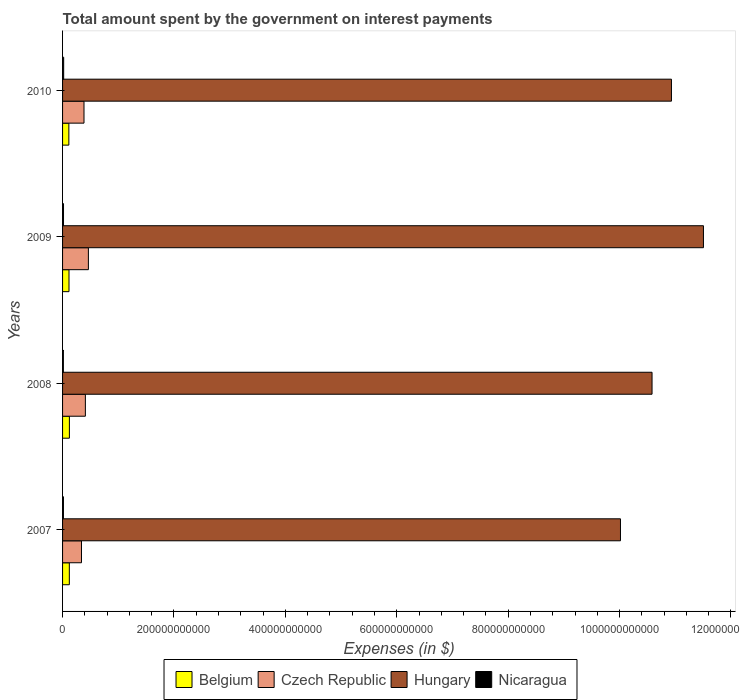How many different coloured bars are there?
Make the answer very short. 4. How many groups of bars are there?
Offer a very short reply. 4. Are the number of bars per tick equal to the number of legend labels?
Your response must be concise. Yes. What is the label of the 3rd group of bars from the top?
Ensure brevity in your answer.  2008. What is the amount spent on interest payments by the government in Hungary in 2007?
Offer a very short reply. 1.00e+12. Across all years, what is the maximum amount spent on interest payments by the government in Nicaragua?
Keep it short and to the point. 1.99e+09. Across all years, what is the minimum amount spent on interest payments by the government in Czech Republic?
Your answer should be compact. 3.40e+1. What is the total amount spent on interest payments by the government in Hungary in the graph?
Offer a very short reply. 4.30e+12. What is the difference between the amount spent on interest payments by the government in Hungary in 2007 and that in 2008?
Ensure brevity in your answer.  -5.67e+1. What is the difference between the amount spent on interest payments by the government in Hungary in 2010 and the amount spent on interest payments by the government in Nicaragua in 2009?
Keep it short and to the point. 1.09e+12. What is the average amount spent on interest payments by the government in Hungary per year?
Make the answer very short. 1.08e+12. In the year 2008, what is the difference between the amount spent on interest payments by the government in Nicaragua and amount spent on interest payments by the government in Hungary?
Give a very brief answer. -1.06e+12. In how many years, is the amount spent on interest payments by the government in Czech Republic greater than 720000000000 $?
Your response must be concise. 0. What is the ratio of the amount spent on interest payments by the government in Belgium in 2008 to that in 2009?
Your answer should be compact. 1.06. Is the amount spent on interest payments by the government in Nicaragua in 2008 less than that in 2009?
Provide a succinct answer. Yes. Is the difference between the amount spent on interest payments by the government in Nicaragua in 2007 and 2010 greater than the difference between the amount spent on interest payments by the government in Hungary in 2007 and 2010?
Offer a terse response. Yes. What is the difference between the highest and the second highest amount spent on interest payments by the government in Hungary?
Provide a succinct answer. 5.74e+1. What is the difference between the highest and the lowest amount spent on interest payments by the government in Czech Republic?
Offer a terse response. 1.24e+1. Is it the case that in every year, the sum of the amount spent on interest payments by the government in Nicaragua and amount spent on interest payments by the government in Hungary is greater than the sum of amount spent on interest payments by the government in Belgium and amount spent on interest payments by the government in Czech Republic?
Offer a very short reply. No. What does the 3rd bar from the top in 2009 represents?
Offer a terse response. Czech Republic. What does the 3rd bar from the bottom in 2009 represents?
Provide a short and direct response. Hungary. How many years are there in the graph?
Make the answer very short. 4. What is the difference between two consecutive major ticks on the X-axis?
Keep it short and to the point. 2.00e+11. How many legend labels are there?
Provide a succinct answer. 4. How are the legend labels stacked?
Offer a terse response. Horizontal. What is the title of the graph?
Your answer should be compact. Total amount spent by the government on interest payments. Does "Luxembourg" appear as one of the legend labels in the graph?
Provide a succinct answer. No. What is the label or title of the X-axis?
Provide a short and direct response. Expenses (in $). What is the label or title of the Y-axis?
Offer a very short reply. Years. What is the Expenses (in $) in Belgium in 2007?
Your answer should be compact. 1.21e+1. What is the Expenses (in $) in Czech Republic in 2007?
Your response must be concise. 3.40e+1. What is the Expenses (in $) of Hungary in 2007?
Provide a succinct answer. 1.00e+12. What is the Expenses (in $) in Nicaragua in 2007?
Provide a short and direct response. 1.58e+09. What is the Expenses (in $) in Belgium in 2008?
Your answer should be compact. 1.23e+1. What is the Expenses (in $) in Czech Republic in 2008?
Keep it short and to the point. 4.09e+1. What is the Expenses (in $) of Hungary in 2008?
Offer a terse response. 1.06e+12. What is the Expenses (in $) in Nicaragua in 2008?
Offer a terse response. 1.45e+09. What is the Expenses (in $) of Belgium in 2009?
Give a very brief answer. 1.16e+1. What is the Expenses (in $) in Czech Republic in 2009?
Give a very brief answer. 4.64e+1. What is the Expenses (in $) of Hungary in 2009?
Provide a short and direct response. 1.15e+12. What is the Expenses (in $) of Nicaragua in 2009?
Keep it short and to the point. 1.71e+09. What is the Expenses (in $) of Belgium in 2010?
Provide a short and direct response. 1.13e+1. What is the Expenses (in $) in Czech Republic in 2010?
Ensure brevity in your answer.  3.85e+1. What is the Expenses (in $) of Hungary in 2010?
Provide a short and direct response. 1.09e+12. What is the Expenses (in $) in Nicaragua in 2010?
Ensure brevity in your answer.  1.99e+09. Across all years, what is the maximum Expenses (in $) in Belgium?
Offer a very short reply. 1.23e+1. Across all years, what is the maximum Expenses (in $) in Czech Republic?
Your answer should be compact. 4.64e+1. Across all years, what is the maximum Expenses (in $) in Hungary?
Offer a terse response. 1.15e+12. Across all years, what is the maximum Expenses (in $) in Nicaragua?
Your answer should be very brief. 1.99e+09. Across all years, what is the minimum Expenses (in $) in Belgium?
Make the answer very short. 1.13e+1. Across all years, what is the minimum Expenses (in $) of Czech Republic?
Make the answer very short. 3.40e+1. Across all years, what is the minimum Expenses (in $) in Hungary?
Your response must be concise. 1.00e+12. Across all years, what is the minimum Expenses (in $) in Nicaragua?
Keep it short and to the point. 1.45e+09. What is the total Expenses (in $) of Belgium in the graph?
Ensure brevity in your answer.  4.72e+1. What is the total Expenses (in $) of Czech Republic in the graph?
Keep it short and to the point. 1.60e+11. What is the total Expenses (in $) of Hungary in the graph?
Your answer should be compact. 4.30e+12. What is the total Expenses (in $) in Nicaragua in the graph?
Offer a very short reply. 6.73e+09. What is the difference between the Expenses (in $) of Belgium in 2007 and that in 2008?
Provide a succinct answer. -1.29e+08. What is the difference between the Expenses (in $) in Czech Republic in 2007 and that in 2008?
Your response must be concise. -6.98e+09. What is the difference between the Expenses (in $) in Hungary in 2007 and that in 2008?
Offer a terse response. -5.67e+1. What is the difference between the Expenses (in $) in Nicaragua in 2007 and that in 2008?
Offer a very short reply. 1.32e+08. What is the difference between the Expenses (in $) in Belgium in 2007 and that in 2009?
Give a very brief answer. 5.78e+08. What is the difference between the Expenses (in $) of Czech Republic in 2007 and that in 2009?
Provide a short and direct response. -1.24e+1. What is the difference between the Expenses (in $) in Hungary in 2007 and that in 2009?
Ensure brevity in your answer.  -1.49e+11. What is the difference between the Expenses (in $) in Nicaragua in 2007 and that in 2009?
Offer a very short reply. -1.31e+08. What is the difference between the Expenses (in $) in Belgium in 2007 and that in 2010?
Ensure brevity in your answer.  8.33e+08. What is the difference between the Expenses (in $) in Czech Republic in 2007 and that in 2010?
Provide a short and direct response. -4.53e+09. What is the difference between the Expenses (in $) in Hungary in 2007 and that in 2010?
Make the answer very short. -9.15e+1. What is the difference between the Expenses (in $) in Nicaragua in 2007 and that in 2010?
Keep it short and to the point. -4.11e+08. What is the difference between the Expenses (in $) in Belgium in 2008 and that in 2009?
Ensure brevity in your answer.  7.06e+08. What is the difference between the Expenses (in $) of Czech Republic in 2008 and that in 2009?
Keep it short and to the point. -5.42e+09. What is the difference between the Expenses (in $) in Hungary in 2008 and that in 2009?
Ensure brevity in your answer.  -9.23e+1. What is the difference between the Expenses (in $) of Nicaragua in 2008 and that in 2009?
Ensure brevity in your answer.  -2.64e+08. What is the difference between the Expenses (in $) in Belgium in 2008 and that in 2010?
Give a very brief answer. 9.62e+08. What is the difference between the Expenses (in $) of Czech Republic in 2008 and that in 2010?
Your answer should be compact. 2.45e+09. What is the difference between the Expenses (in $) of Hungary in 2008 and that in 2010?
Your answer should be compact. -3.49e+1. What is the difference between the Expenses (in $) of Nicaragua in 2008 and that in 2010?
Ensure brevity in your answer.  -5.43e+08. What is the difference between the Expenses (in $) of Belgium in 2009 and that in 2010?
Offer a terse response. 2.56e+08. What is the difference between the Expenses (in $) in Czech Republic in 2009 and that in 2010?
Your answer should be very brief. 7.87e+09. What is the difference between the Expenses (in $) of Hungary in 2009 and that in 2010?
Offer a very short reply. 5.74e+1. What is the difference between the Expenses (in $) of Nicaragua in 2009 and that in 2010?
Provide a succinct answer. -2.79e+08. What is the difference between the Expenses (in $) of Belgium in 2007 and the Expenses (in $) of Czech Republic in 2008?
Your answer should be compact. -2.88e+1. What is the difference between the Expenses (in $) of Belgium in 2007 and the Expenses (in $) of Hungary in 2008?
Provide a short and direct response. -1.05e+12. What is the difference between the Expenses (in $) in Belgium in 2007 and the Expenses (in $) in Nicaragua in 2008?
Offer a terse response. 1.07e+1. What is the difference between the Expenses (in $) of Czech Republic in 2007 and the Expenses (in $) of Hungary in 2008?
Keep it short and to the point. -1.02e+12. What is the difference between the Expenses (in $) in Czech Republic in 2007 and the Expenses (in $) in Nicaragua in 2008?
Keep it short and to the point. 3.25e+1. What is the difference between the Expenses (in $) in Hungary in 2007 and the Expenses (in $) in Nicaragua in 2008?
Keep it short and to the point. 1.00e+12. What is the difference between the Expenses (in $) of Belgium in 2007 and the Expenses (in $) of Czech Republic in 2009?
Provide a succinct answer. -3.42e+1. What is the difference between the Expenses (in $) of Belgium in 2007 and the Expenses (in $) of Hungary in 2009?
Ensure brevity in your answer.  -1.14e+12. What is the difference between the Expenses (in $) in Belgium in 2007 and the Expenses (in $) in Nicaragua in 2009?
Ensure brevity in your answer.  1.04e+1. What is the difference between the Expenses (in $) in Czech Republic in 2007 and the Expenses (in $) in Hungary in 2009?
Give a very brief answer. -1.12e+12. What is the difference between the Expenses (in $) in Czech Republic in 2007 and the Expenses (in $) in Nicaragua in 2009?
Make the answer very short. 3.23e+1. What is the difference between the Expenses (in $) of Hungary in 2007 and the Expenses (in $) of Nicaragua in 2009?
Offer a very short reply. 1.00e+12. What is the difference between the Expenses (in $) of Belgium in 2007 and the Expenses (in $) of Czech Republic in 2010?
Provide a succinct answer. -2.64e+1. What is the difference between the Expenses (in $) of Belgium in 2007 and the Expenses (in $) of Hungary in 2010?
Your response must be concise. -1.08e+12. What is the difference between the Expenses (in $) in Belgium in 2007 and the Expenses (in $) in Nicaragua in 2010?
Provide a succinct answer. 1.01e+1. What is the difference between the Expenses (in $) of Czech Republic in 2007 and the Expenses (in $) of Hungary in 2010?
Provide a short and direct response. -1.06e+12. What is the difference between the Expenses (in $) of Czech Republic in 2007 and the Expenses (in $) of Nicaragua in 2010?
Ensure brevity in your answer.  3.20e+1. What is the difference between the Expenses (in $) in Hungary in 2007 and the Expenses (in $) in Nicaragua in 2010?
Ensure brevity in your answer.  1.00e+12. What is the difference between the Expenses (in $) in Belgium in 2008 and the Expenses (in $) in Czech Republic in 2009?
Provide a short and direct response. -3.41e+1. What is the difference between the Expenses (in $) of Belgium in 2008 and the Expenses (in $) of Hungary in 2009?
Your response must be concise. -1.14e+12. What is the difference between the Expenses (in $) in Belgium in 2008 and the Expenses (in $) in Nicaragua in 2009?
Ensure brevity in your answer.  1.05e+1. What is the difference between the Expenses (in $) of Czech Republic in 2008 and the Expenses (in $) of Hungary in 2009?
Make the answer very short. -1.11e+12. What is the difference between the Expenses (in $) in Czech Republic in 2008 and the Expenses (in $) in Nicaragua in 2009?
Your answer should be very brief. 3.92e+1. What is the difference between the Expenses (in $) in Hungary in 2008 and the Expenses (in $) in Nicaragua in 2009?
Provide a short and direct response. 1.06e+12. What is the difference between the Expenses (in $) of Belgium in 2008 and the Expenses (in $) of Czech Republic in 2010?
Your answer should be very brief. -2.62e+1. What is the difference between the Expenses (in $) in Belgium in 2008 and the Expenses (in $) in Hungary in 2010?
Your answer should be compact. -1.08e+12. What is the difference between the Expenses (in $) in Belgium in 2008 and the Expenses (in $) in Nicaragua in 2010?
Offer a terse response. 1.03e+1. What is the difference between the Expenses (in $) of Czech Republic in 2008 and the Expenses (in $) of Hungary in 2010?
Provide a succinct answer. -1.05e+12. What is the difference between the Expenses (in $) of Czech Republic in 2008 and the Expenses (in $) of Nicaragua in 2010?
Ensure brevity in your answer.  3.90e+1. What is the difference between the Expenses (in $) in Hungary in 2008 and the Expenses (in $) in Nicaragua in 2010?
Your response must be concise. 1.06e+12. What is the difference between the Expenses (in $) of Belgium in 2009 and the Expenses (in $) of Czech Republic in 2010?
Offer a terse response. -2.69e+1. What is the difference between the Expenses (in $) in Belgium in 2009 and the Expenses (in $) in Hungary in 2010?
Your response must be concise. -1.08e+12. What is the difference between the Expenses (in $) in Belgium in 2009 and the Expenses (in $) in Nicaragua in 2010?
Your answer should be very brief. 9.56e+09. What is the difference between the Expenses (in $) of Czech Republic in 2009 and the Expenses (in $) of Hungary in 2010?
Offer a terse response. -1.05e+12. What is the difference between the Expenses (in $) in Czech Republic in 2009 and the Expenses (in $) in Nicaragua in 2010?
Keep it short and to the point. 4.44e+1. What is the difference between the Expenses (in $) in Hungary in 2009 and the Expenses (in $) in Nicaragua in 2010?
Make the answer very short. 1.15e+12. What is the average Expenses (in $) in Belgium per year?
Keep it short and to the point. 1.18e+1. What is the average Expenses (in $) in Czech Republic per year?
Keep it short and to the point. 3.99e+1. What is the average Expenses (in $) in Hungary per year?
Keep it short and to the point. 1.08e+12. What is the average Expenses (in $) of Nicaragua per year?
Keep it short and to the point. 1.68e+09. In the year 2007, what is the difference between the Expenses (in $) of Belgium and Expenses (in $) of Czech Republic?
Keep it short and to the point. -2.18e+1. In the year 2007, what is the difference between the Expenses (in $) in Belgium and Expenses (in $) in Hungary?
Your response must be concise. -9.89e+11. In the year 2007, what is the difference between the Expenses (in $) of Belgium and Expenses (in $) of Nicaragua?
Your answer should be very brief. 1.06e+1. In the year 2007, what is the difference between the Expenses (in $) of Czech Republic and Expenses (in $) of Hungary?
Ensure brevity in your answer.  -9.68e+11. In the year 2007, what is the difference between the Expenses (in $) of Czech Republic and Expenses (in $) of Nicaragua?
Your response must be concise. 3.24e+1. In the year 2007, what is the difference between the Expenses (in $) of Hungary and Expenses (in $) of Nicaragua?
Provide a short and direct response. 1.00e+12. In the year 2008, what is the difference between the Expenses (in $) in Belgium and Expenses (in $) in Czech Republic?
Offer a terse response. -2.87e+1. In the year 2008, what is the difference between the Expenses (in $) of Belgium and Expenses (in $) of Hungary?
Ensure brevity in your answer.  -1.05e+12. In the year 2008, what is the difference between the Expenses (in $) in Belgium and Expenses (in $) in Nicaragua?
Offer a very short reply. 1.08e+1. In the year 2008, what is the difference between the Expenses (in $) in Czech Republic and Expenses (in $) in Hungary?
Offer a terse response. -1.02e+12. In the year 2008, what is the difference between the Expenses (in $) in Czech Republic and Expenses (in $) in Nicaragua?
Ensure brevity in your answer.  3.95e+1. In the year 2008, what is the difference between the Expenses (in $) in Hungary and Expenses (in $) in Nicaragua?
Offer a terse response. 1.06e+12. In the year 2009, what is the difference between the Expenses (in $) of Belgium and Expenses (in $) of Czech Republic?
Give a very brief answer. -3.48e+1. In the year 2009, what is the difference between the Expenses (in $) of Belgium and Expenses (in $) of Hungary?
Provide a short and direct response. -1.14e+12. In the year 2009, what is the difference between the Expenses (in $) of Belgium and Expenses (in $) of Nicaragua?
Make the answer very short. 9.84e+09. In the year 2009, what is the difference between the Expenses (in $) of Czech Republic and Expenses (in $) of Hungary?
Your answer should be compact. -1.10e+12. In the year 2009, what is the difference between the Expenses (in $) in Czech Republic and Expenses (in $) in Nicaragua?
Ensure brevity in your answer.  4.47e+1. In the year 2009, what is the difference between the Expenses (in $) in Hungary and Expenses (in $) in Nicaragua?
Offer a terse response. 1.15e+12. In the year 2010, what is the difference between the Expenses (in $) of Belgium and Expenses (in $) of Czech Republic?
Your answer should be very brief. -2.72e+1. In the year 2010, what is the difference between the Expenses (in $) of Belgium and Expenses (in $) of Hungary?
Your answer should be very brief. -1.08e+12. In the year 2010, what is the difference between the Expenses (in $) in Belgium and Expenses (in $) in Nicaragua?
Provide a short and direct response. 9.31e+09. In the year 2010, what is the difference between the Expenses (in $) in Czech Republic and Expenses (in $) in Hungary?
Your response must be concise. -1.05e+12. In the year 2010, what is the difference between the Expenses (in $) of Czech Republic and Expenses (in $) of Nicaragua?
Your response must be concise. 3.65e+1. In the year 2010, what is the difference between the Expenses (in $) in Hungary and Expenses (in $) in Nicaragua?
Make the answer very short. 1.09e+12. What is the ratio of the Expenses (in $) in Czech Republic in 2007 to that in 2008?
Your answer should be very brief. 0.83. What is the ratio of the Expenses (in $) of Hungary in 2007 to that in 2008?
Offer a very short reply. 0.95. What is the ratio of the Expenses (in $) of Nicaragua in 2007 to that in 2008?
Ensure brevity in your answer.  1.09. What is the ratio of the Expenses (in $) in Belgium in 2007 to that in 2009?
Keep it short and to the point. 1.05. What is the ratio of the Expenses (in $) in Czech Republic in 2007 to that in 2009?
Offer a very short reply. 0.73. What is the ratio of the Expenses (in $) in Hungary in 2007 to that in 2009?
Make the answer very short. 0.87. What is the ratio of the Expenses (in $) of Nicaragua in 2007 to that in 2009?
Offer a very short reply. 0.92. What is the ratio of the Expenses (in $) of Belgium in 2007 to that in 2010?
Offer a very short reply. 1.07. What is the ratio of the Expenses (in $) in Czech Republic in 2007 to that in 2010?
Make the answer very short. 0.88. What is the ratio of the Expenses (in $) in Hungary in 2007 to that in 2010?
Give a very brief answer. 0.92. What is the ratio of the Expenses (in $) in Nicaragua in 2007 to that in 2010?
Offer a very short reply. 0.79. What is the ratio of the Expenses (in $) of Belgium in 2008 to that in 2009?
Offer a terse response. 1.06. What is the ratio of the Expenses (in $) in Czech Republic in 2008 to that in 2009?
Your answer should be very brief. 0.88. What is the ratio of the Expenses (in $) in Hungary in 2008 to that in 2009?
Keep it short and to the point. 0.92. What is the ratio of the Expenses (in $) in Nicaragua in 2008 to that in 2009?
Your answer should be compact. 0.85. What is the ratio of the Expenses (in $) in Belgium in 2008 to that in 2010?
Ensure brevity in your answer.  1.09. What is the ratio of the Expenses (in $) of Czech Republic in 2008 to that in 2010?
Offer a very short reply. 1.06. What is the ratio of the Expenses (in $) of Hungary in 2008 to that in 2010?
Provide a short and direct response. 0.97. What is the ratio of the Expenses (in $) in Nicaragua in 2008 to that in 2010?
Your answer should be very brief. 0.73. What is the ratio of the Expenses (in $) in Belgium in 2009 to that in 2010?
Your answer should be very brief. 1.02. What is the ratio of the Expenses (in $) of Czech Republic in 2009 to that in 2010?
Provide a succinct answer. 1.2. What is the ratio of the Expenses (in $) in Hungary in 2009 to that in 2010?
Offer a very short reply. 1.05. What is the ratio of the Expenses (in $) of Nicaragua in 2009 to that in 2010?
Ensure brevity in your answer.  0.86. What is the difference between the highest and the second highest Expenses (in $) of Belgium?
Offer a terse response. 1.29e+08. What is the difference between the highest and the second highest Expenses (in $) of Czech Republic?
Keep it short and to the point. 5.42e+09. What is the difference between the highest and the second highest Expenses (in $) in Hungary?
Offer a terse response. 5.74e+1. What is the difference between the highest and the second highest Expenses (in $) of Nicaragua?
Your answer should be very brief. 2.79e+08. What is the difference between the highest and the lowest Expenses (in $) of Belgium?
Your answer should be very brief. 9.62e+08. What is the difference between the highest and the lowest Expenses (in $) in Czech Republic?
Your response must be concise. 1.24e+1. What is the difference between the highest and the lowest Expenses (in $) in Hungary?
Offer a terse response. 1.49e+11. What is the difference between the highest and the lowest Expenses (in $) of Nicaragua?
Keep it short and to the point. 5.43e+08. 